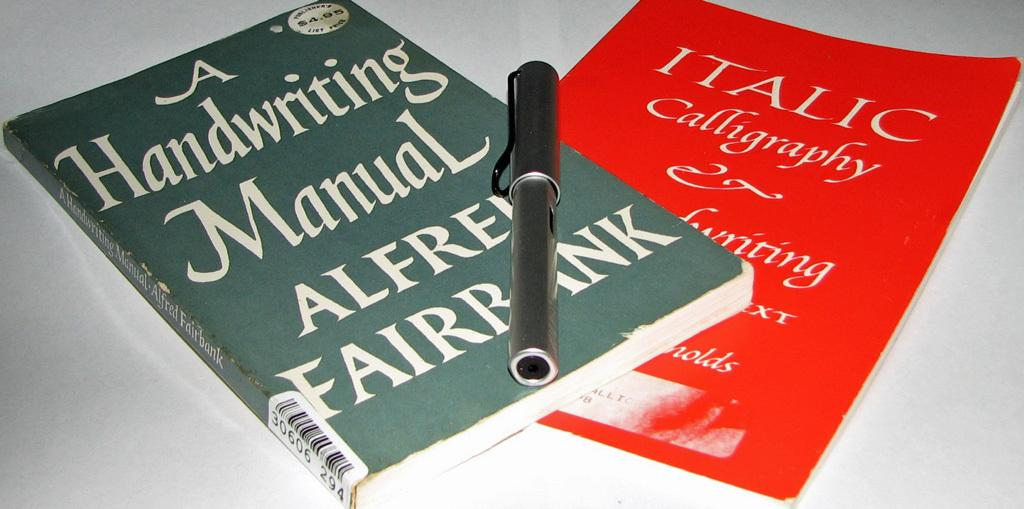Provide a one-sentence caption for the provided image. two books stack with one titled A Handwriting Manual by Alfred Fairbank. 